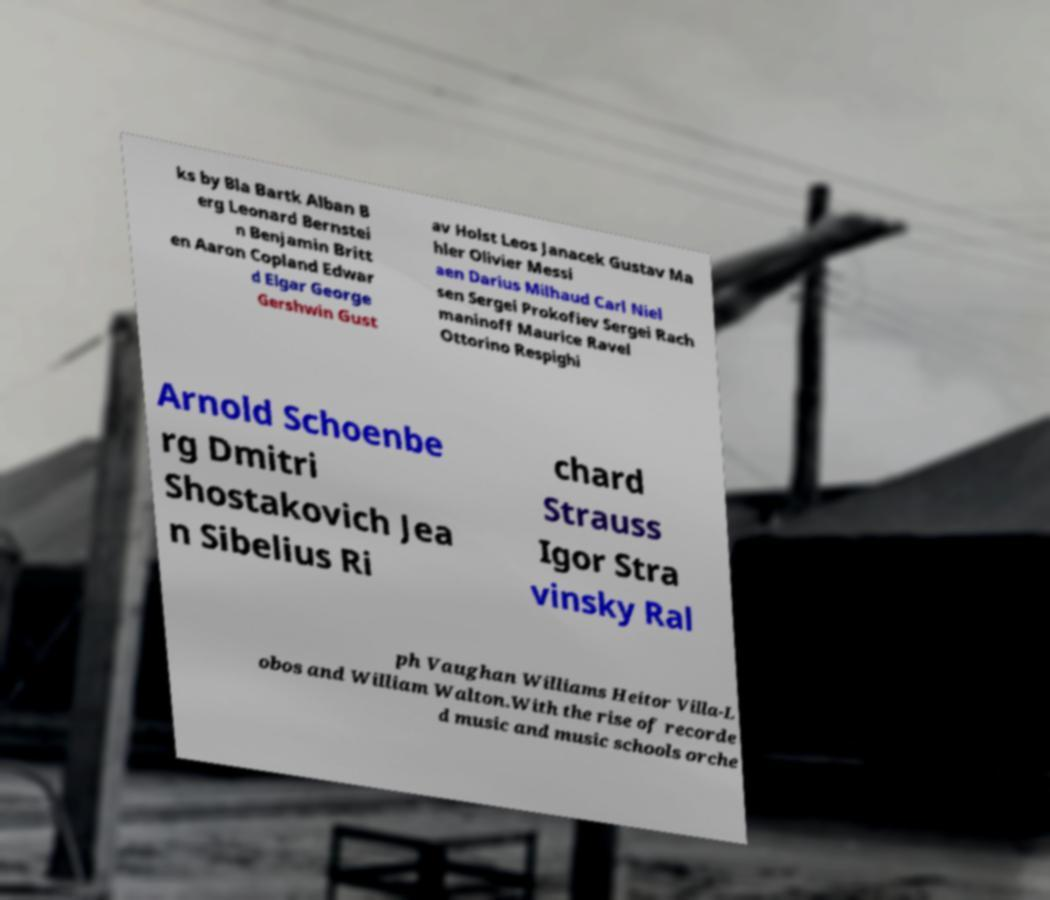Can you accurately transcribe the text from the provided image for me? ks by Bla Bartk Alban B erg Leonard Bernstei n Benjamin Britt en Aaron Copland Edwar d Elgar George Gershwin Gust av Holst Leos Janacek Gustav Ma hler Olivier Messi aen Darius Milhaud Carl Niel sen Sergei Prokofiev Sergei Rach maninoff Maurice Ravel Ottorino Respighi Arnold Schoenbe rg Dmitri Shostakovich Jea n Sibelius Ri chard Strauss Igor Stra vinsky Ral ph Vaughan Williams Heitor Villa-L obos and William Walton.With the rise of recorde d music and music schools orche 